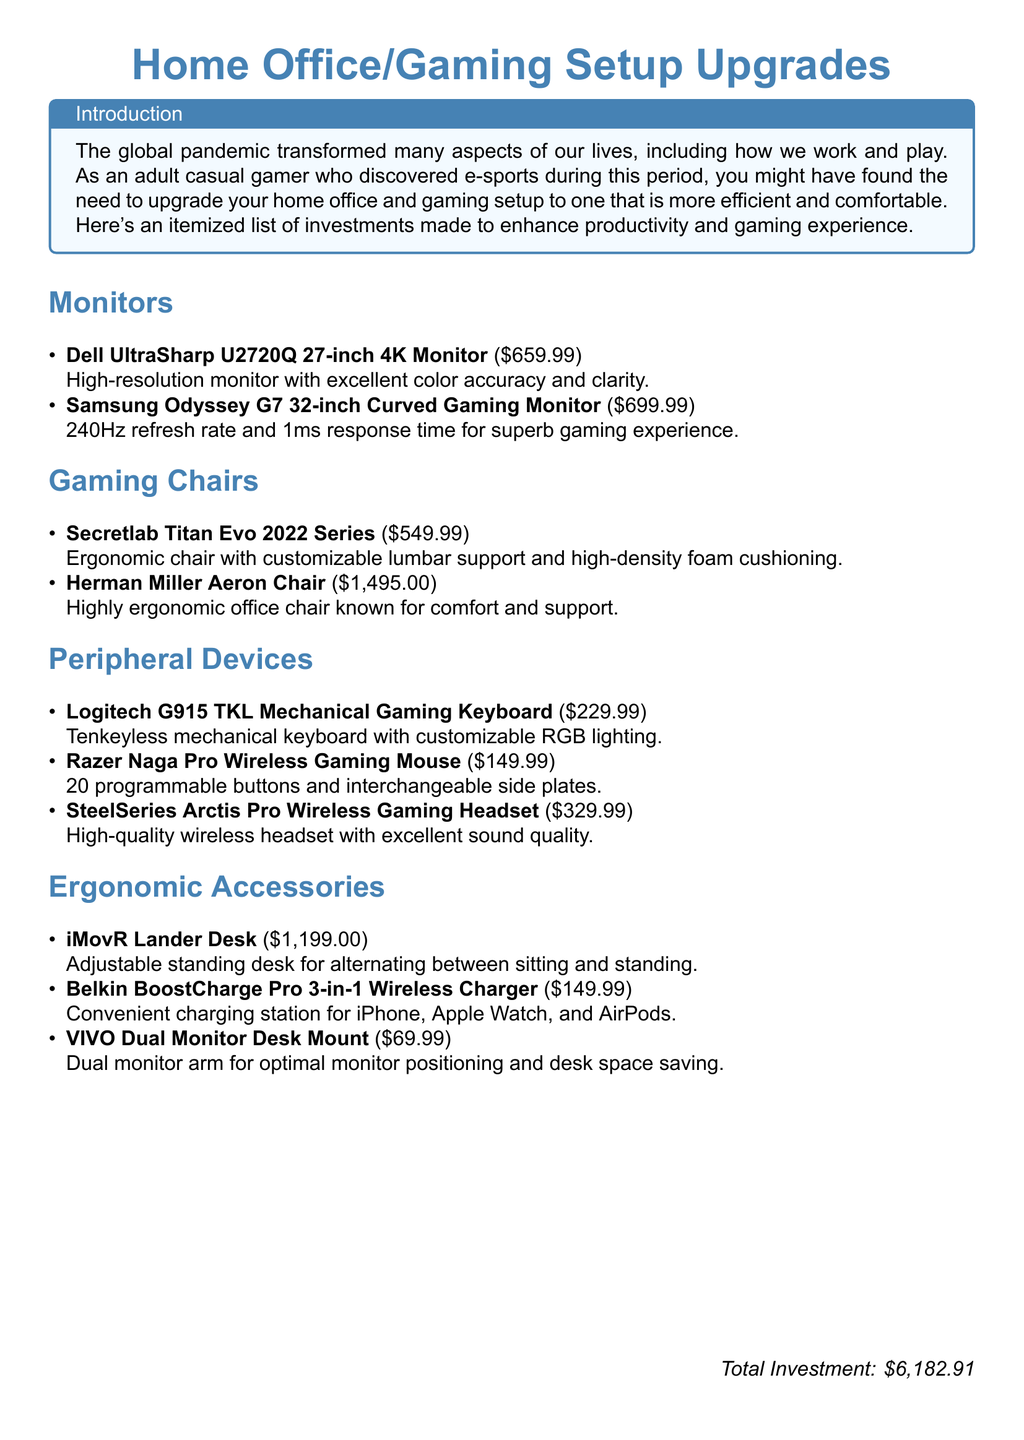What is the total investment? The total investment is the sum of all costs for the items listed in the document, which amounts to $6,182.91.
Answer: $6,182.91 How much does the Dell UltraSharp U2720Q 27-inch 4K Monitor cost? The cost of the Dell UltraSharp U2720Q 27-inch 4K Monitor is specified in the document as $659.99.
Answer: $659.99 What type of gaming chair is the Secretlab Titan Evo 2022 Series? The Secretlab Titan Evo 2022 Series is described as an ergonomic chair.
Answer: Ergonomic chair How many programmable buttons does the Razer Naga Pro Wireless Gaming Mouse have? The document states that the Razer Naga Pro Wireless Gaming Mouse has 20 programmable buttons.
Answer: 20 What accessory is listed for optimal monitor positioning? The document lists the VIVO Dual Monitor Desk Mount as an accessory for optimal monitor positioning.
Answer: VIVO Dual Monitor Desk Mount What feature does the SteelSeries Arctis Pro Wireless Gaming Headset have? The SteelSeries Arctis Pro Wireless Gaming Headset is noted for its excellent sound quality in the document.
Answer: Excellent sound quality What is the price of the Herman Miller Aeron Chair? The document states that the price of the Herman Miller Aeron Chair is $1,495.00.
Answer: $1,495.00 What is the purpose of the iMovR Lander Desk? The iMovR Lander Desk is intended for alternating between sitting and standing.
Answer: Alternating between sitting and standing Which item is described as having customizable RGB lighting? The Logitech G915 TKL Mechanical Gaming Keyboard is described as having customizable RGB lighting.
Answer: Logitech G915 TKL Mechanical Gaming Keyboard 